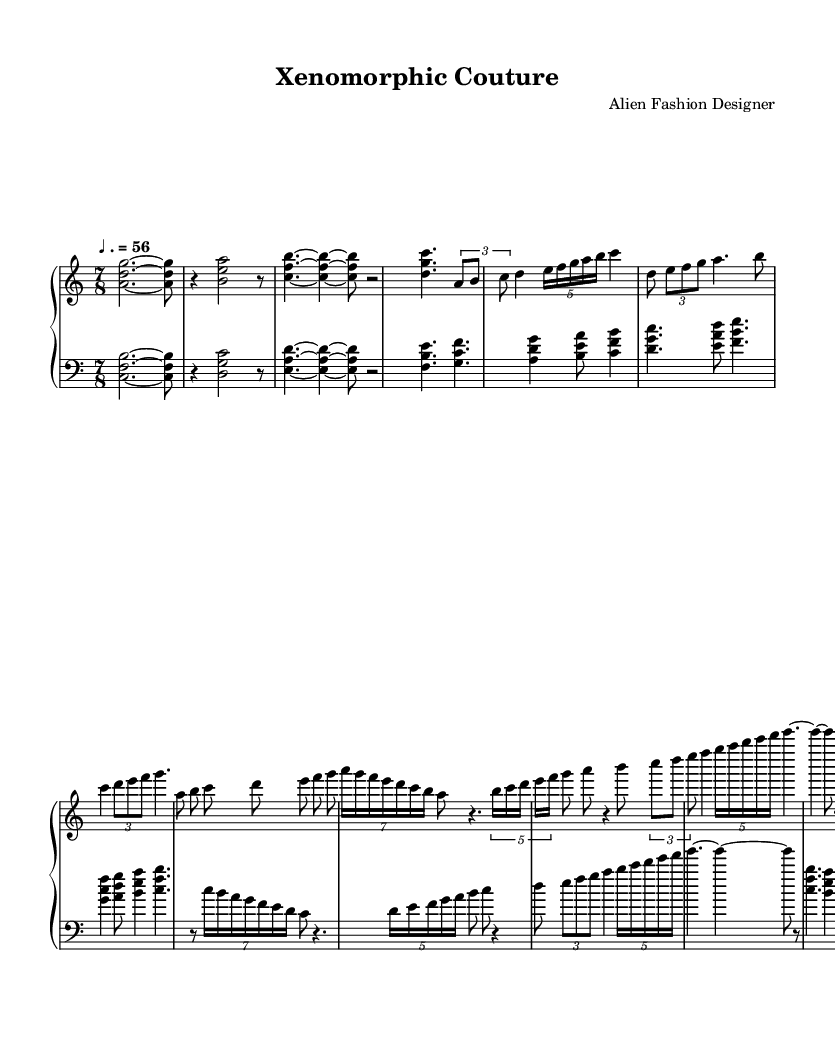What is the time signature of this music? The time signature is located at the beginning of the sheet music, showing a "7/8" time signature. This indicates there are seven beats in each measure, with each eighth note receiving one beat.
Answer: 7/8 What is the tempo marking for this piece? The tempo marking can be found in the sheet music as "♩. = 56", indicating that the quarter note (♩) is set to a speed of 56 beats per minute.
Answer: 56 How many sections are visually identifiable in the music? By examining the structure of the music, we can identify three distinct sections labeled in the score: the Introduction, Section A, and Section B. Each section has unique musical phrases.
Answer: 3 What is the clef used for the upper staff? The clef at the beginning of the upper staff is a treble clef, which indicates the notes are primarily in a higher pitch range. It visually resembles an ornate letter 'G'.
Answer: Treble Which section contains the largest note groupings? Upon observing the music, Section B contains longer note groupings and many tuplets with seven notes, making it visually more complex compared to the other sections, which mainly use simpler groupings.
Answer: Section B How does the Coda section end the piece? The Coda section concludes with a final measure consisting of a whole note, indicated as "<d g c>1", followed by a rest, which creates a strong sense of closure.
Answer: Whole note 